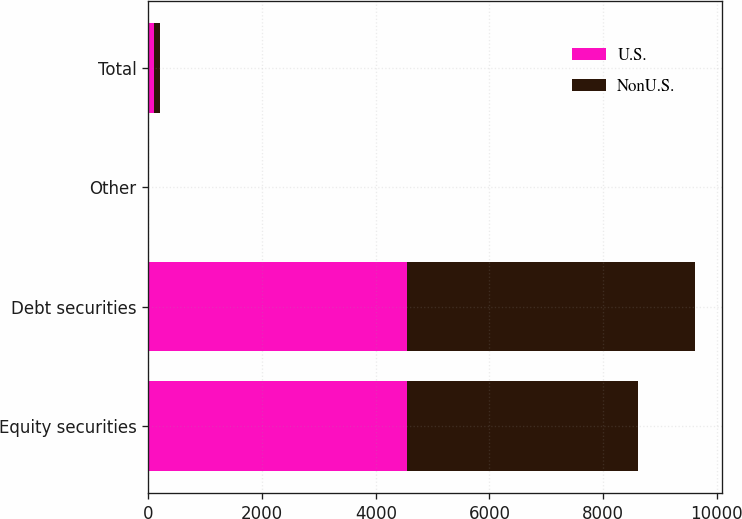Convert chart. <chart><loc_0><loc_0><loc_500><loc_500><stacked_bar_chart><ecel><fcel>Equity securities<fcel>Debt securities<fcel>Other<fcel>Total<nl><fcel>U.S.<fcel>4555<fcel>4555<fcel>5<fcel>100<nl><fcel>NonU.S.<fcel>4050<fcel>5060<fcel>5<fcel>100<nl></chart> 